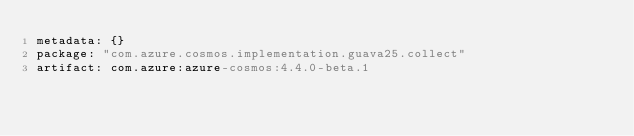Convert code to text. <code><loc_0><loc_0><loc_500><loc_500><_YAML_>metadata: {}
package: "com.azure.cosmos.implementation.guava25.collect"
artifact: com.azure:azure-cosmos:4.4.0-beta.1
</code> 